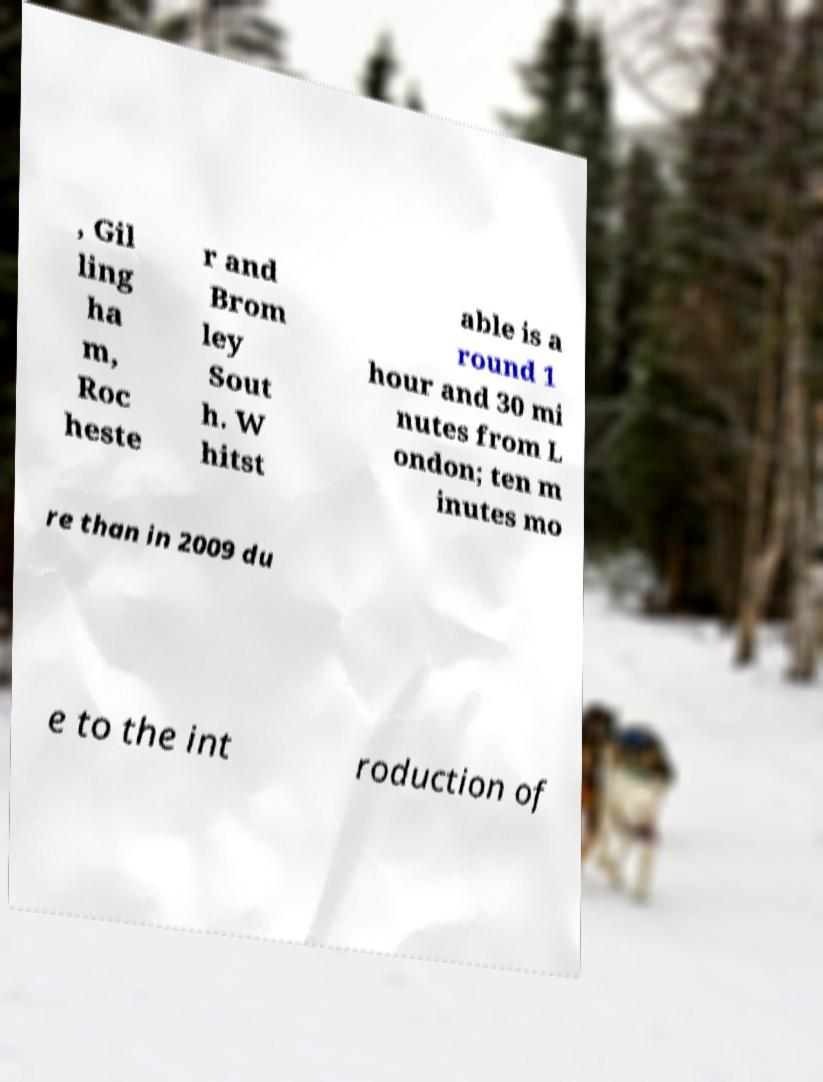I need the written content from this picture converted into text. Can you do that? , Gil ling ha m, Roc heste r and Brom ley Sout h. W hitst able is a round 1 hour and 30 mi nutes from L ondon; ten m inutes mo re than in 2009 du e to the int roduction of 